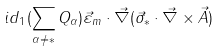Convert formula to latex. <formula><loc_0><loc_0><loc_500><loc_500>i d _ { 1 } ( \sum _ { \alpha \neq * } Q _ { \alpha } ) \vec { \varepsilon } _ { m } \cdot \vec { \nabla } ( \vec { \sigma } _ { * } \cdot \vec { \nabla } \times \vec { A } )</formula> 